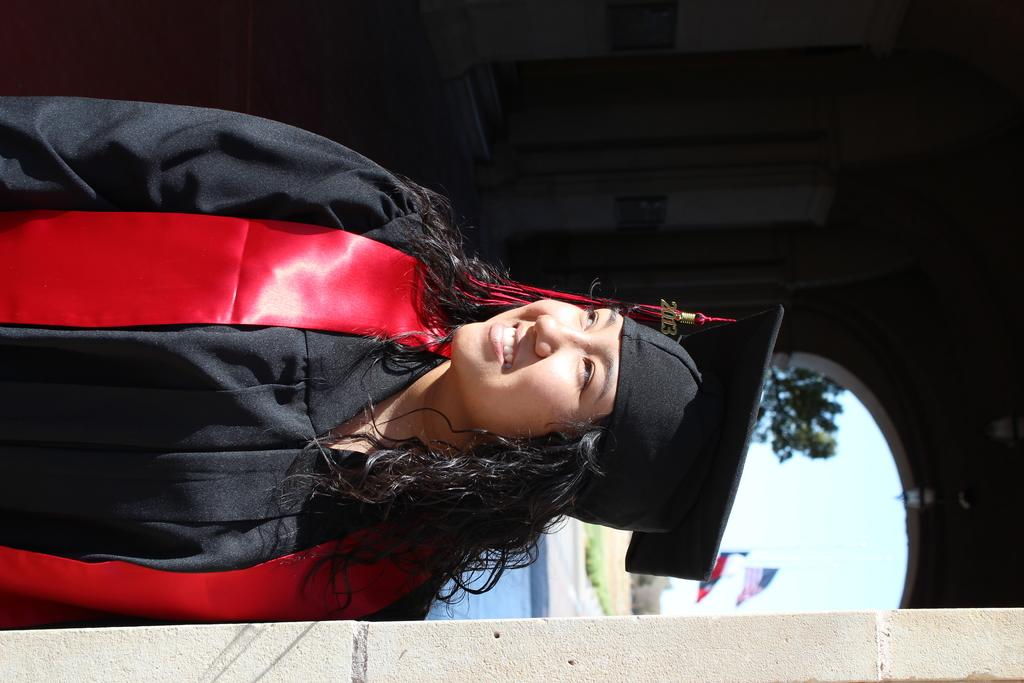What is the main subject of the image? There is a woman standing in the center of the image. What is the woman doing in the image? The woman is smiling in the image. What can be seen in the background of the image? There is a tree and flags in the background of the image. What type of ground is visible in the image? There is grass on the ground in the image. How many fingers can be seen in the image? There are no fingers visible in the image. 